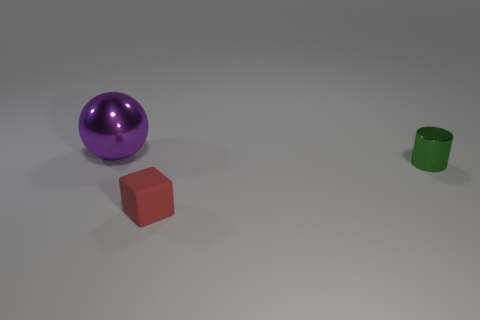Add 1 big blue metallic objects. How many objects exist? 4 Subtract all cylinders. How many objects are left? 2 Subtract all purple shiny balls. Subtract all small metallic cylinders. How many objects are left? 1 Add 3 red cubes. How many red cubes are left? 4 Add 2 brown cylinders. How many brown cylinders exist? 2 Subtract 0 blue blocks. How many objects are left? 3 